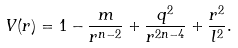<formula> <loc_0><loc_0><loc_500><loc_500>V ( r ) = 1 - \frac { m } { r ^ { n - 2 } } + \frac { q ^ { 2 } } { r ^ { 2 n - 4 } } + \frac { r ^ { 2 } } { l ^ { 2 } } .</formula> 